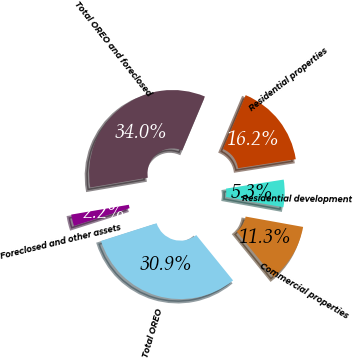Convert chart to OTSL. <chart><loc_0><loc_0><loc_500><loc_500><pie_chart><fcel>Residential properties<fcel>Residential development<fcel>Commercial properties<fcel>Total OREO<fcel>Foreclosed and other assets<fcel>Total OREO and foreclosed<nl><fcel>16.19%<fcel>5.31%<fcel>11.31%<fcel>30.94%<fcel>2.22%<fcel>34.03%<nl></chart> 